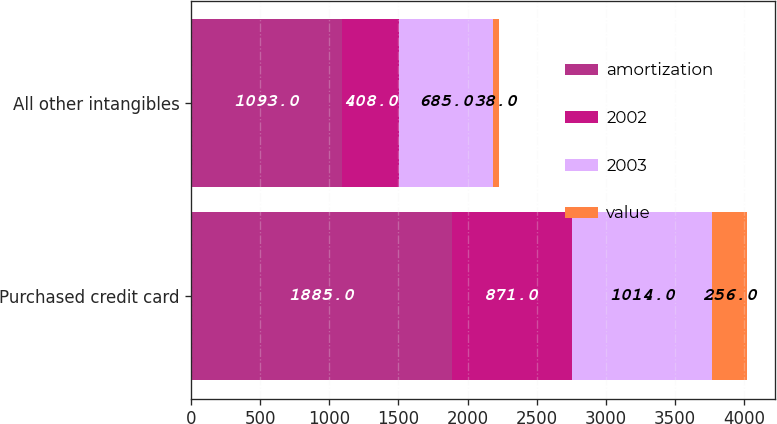<chart> <loc_0><loc_0><loc_500><loc_500><stacked_bar_chart><ecel><fcel>Purchased credit card<fcel>All other intangibles<nl><fcel>amortization<fcel>1885<fcel>1093<nl><fcel>2002<fcel>871<fcel>408<nl><fcel>2003<fcel>1014<fcel>685<nl><fcel>value<fcel>256<fcel>38<nl></chart> 